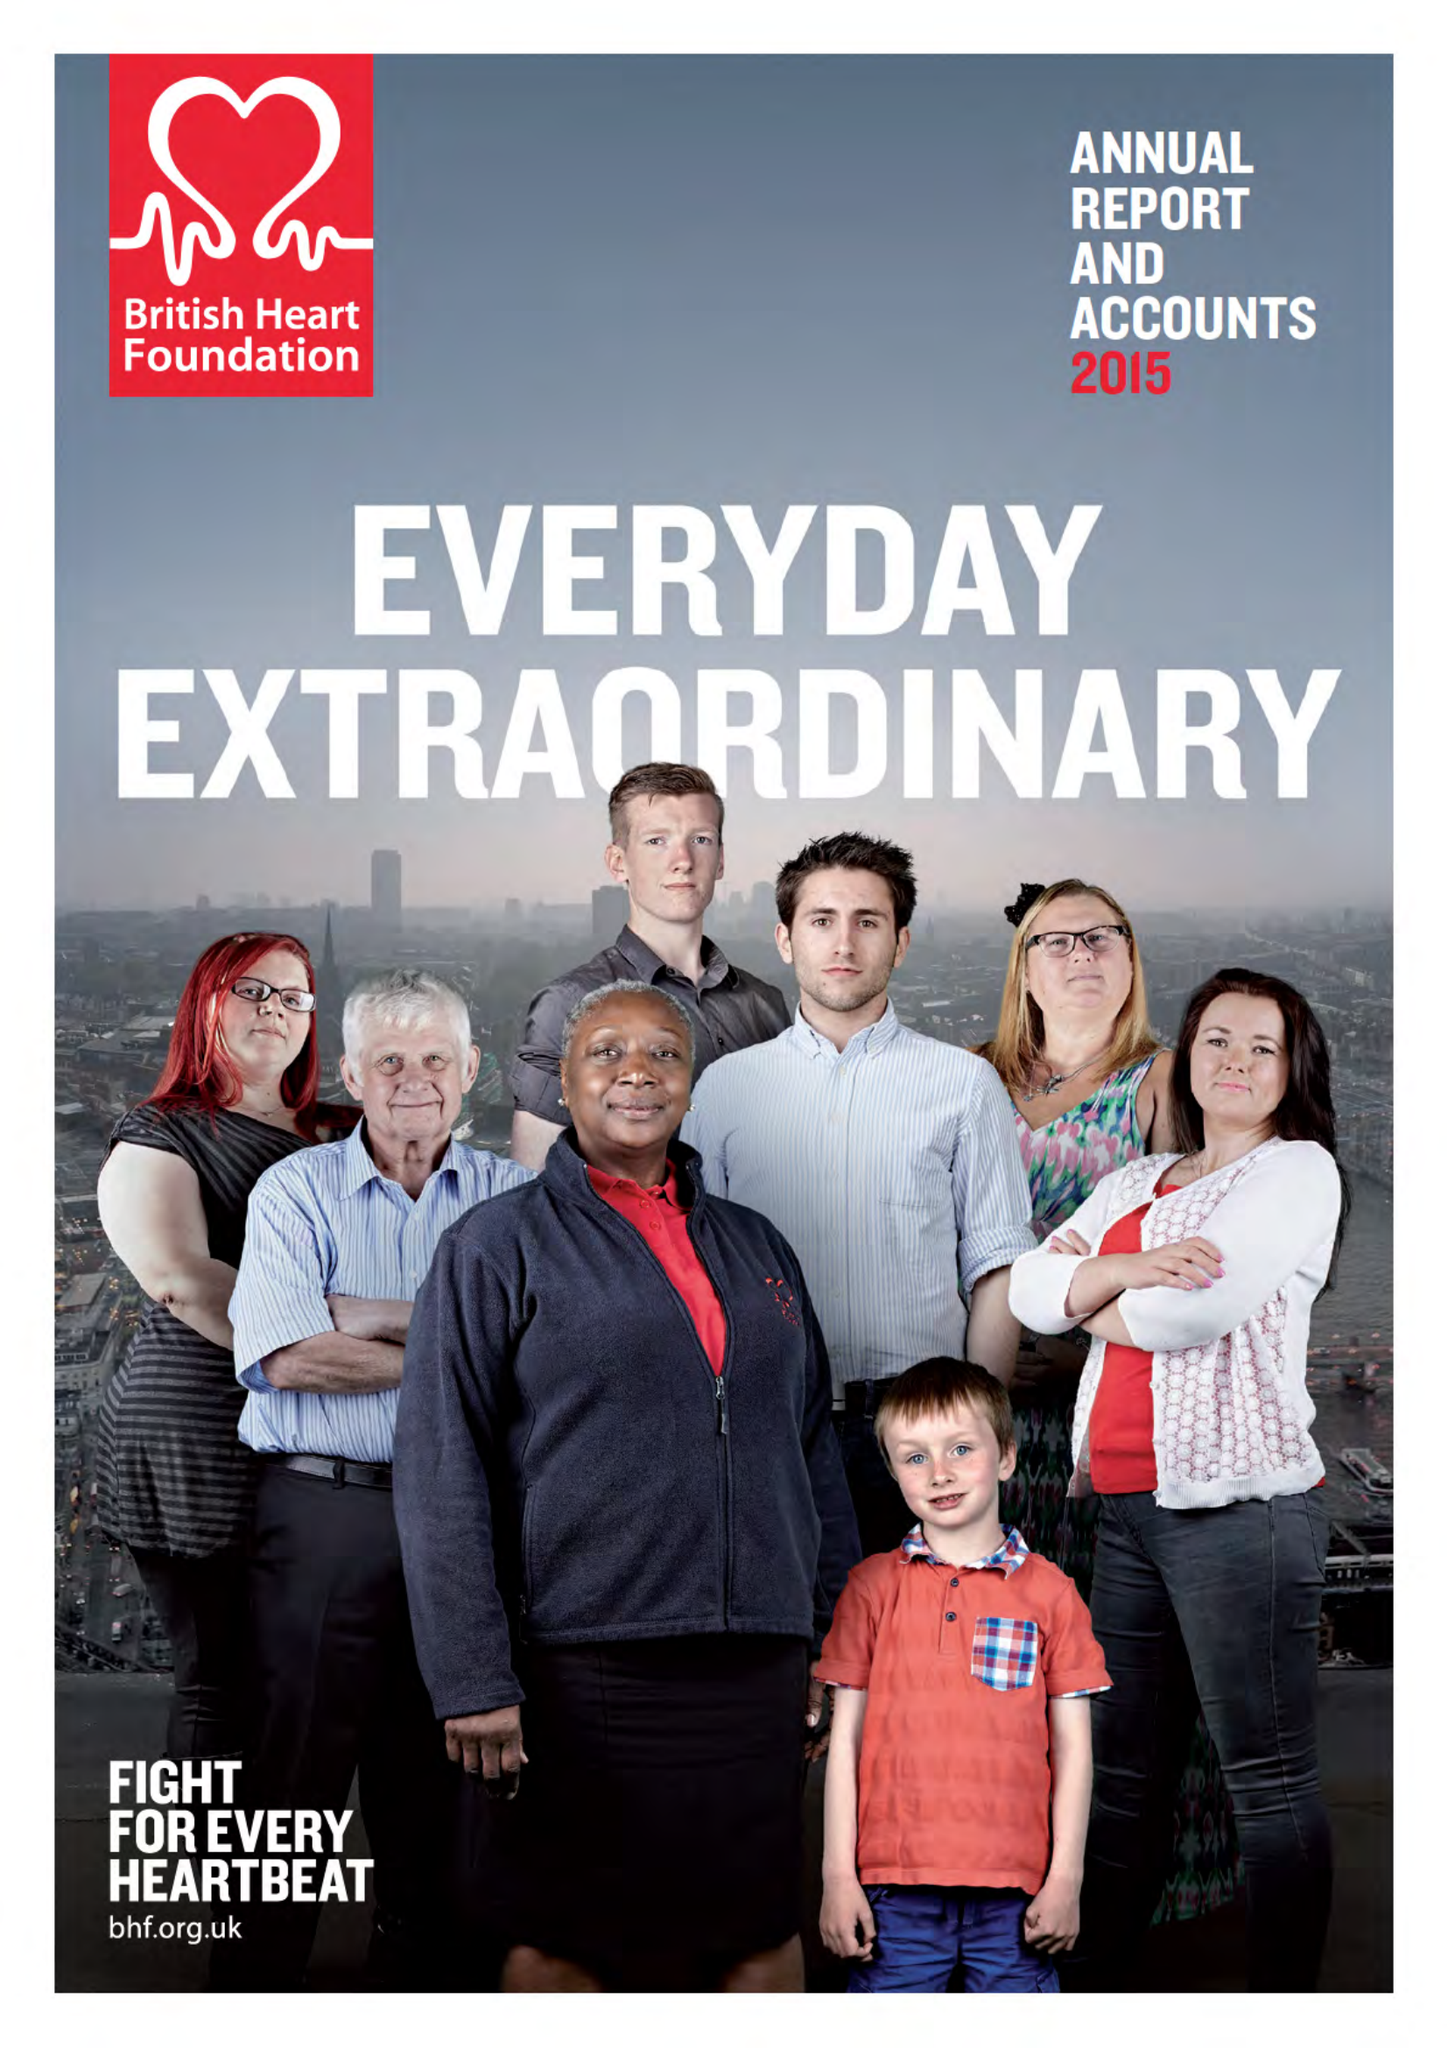What is the value for the address__street_line?
Answer the question using a single word or phrase. 180 HAMPSTEAD ROAD 